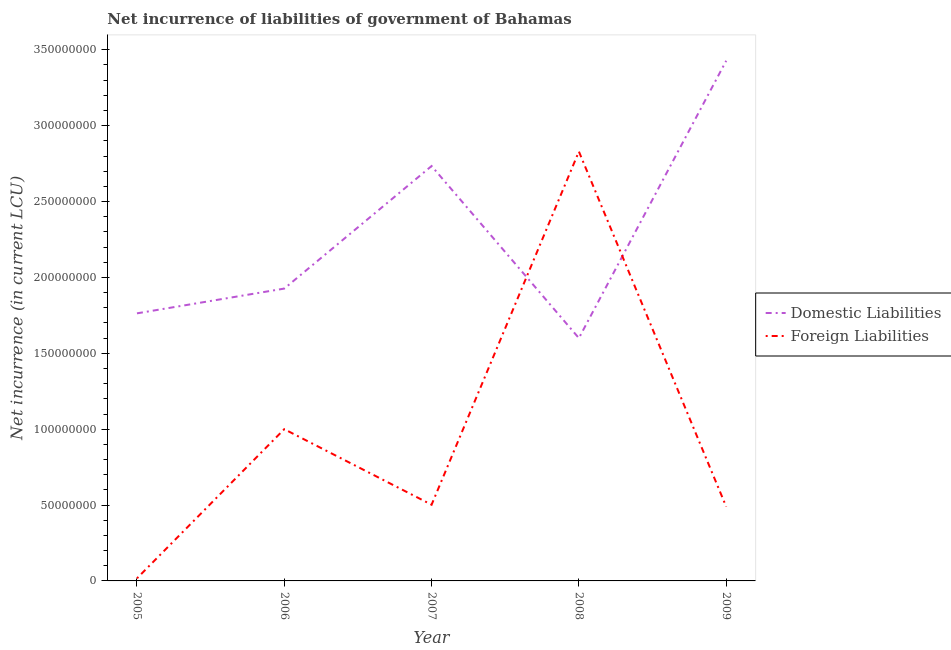How many different coloured lines are there?
Provide a short and direct response. 2. What is the net incurrence of domestic liabilities in 2007?
Offer a terse response. 2.73e+08. Across all years, what is the maximum net incurrence of domestic liabilities?
Make the answer very short. 3.43e+08. Across all years, what is the minimum net incurrence of foreign liabilities?
Offer a terse response. 1.70e+06. In which year was the net incurrence of foreign liabilities maximum?
Ensure brevity in your answer.  2008. What is the total net incurrence of foreign liabilities in the graph?
Provide a succinct answer. 4.84e+08. What is the difference between the net incurrence of domestic liabilities in 2006 and that in 2007?
Ensure brevity in your answer.  -8.08e+07. What is the difference between the net incurrence of foreign liabilities in 2009 and the net incurrence of domestic liabilities in 2005?
Provide a short and direct response. -1.27e+08. What is the average net incurrence of domestic liabilities per year?
Your answer should be very brief. 2.29e+08. In the year 2008, what is the difference between the net incurrence of domestic liabilities and net incurrence of foreign liabilities?
Offer a very short reply. -1.23e+08. In how many years, is the net incurrence of domestic liabilities greater than 220000000 LCU?
Provide a short and direct response. 2. What is the ratio of the net incurrence of domestic liabilities in 2006 to that in 2007?
Ensure brevity in your answer.  0.7. What is the difference between the highest and the second highest net incurrence of domestic liabilities?
Ensure brevity in your answer.  6.94e+07. What is the difference between the highest and the lowest net incurrence of foreign liabilities?
Make the answer very short. 2.81e+08. Is the net incurrence of domestic liabilities strictly less than the net incurrence of foreign liabilities over the years?
Your answer should be compact. No. How many lines are there?
Offer a terse response. 2. Does the graph contain any zero values?
Make the answer very short. No. Does the graph contain grids?
Your answer should be very brief. No. What is the title of the graph?
Offer a terse response. Net incurrence of liabilities of government of Bahamas. Does "Central government" appear as one of the legend labels in the graph?
Offer a very short reply. No. What is the label or title of the Y-axis?
Your answer should be compact. Net incurrence (in current LCU). What is the Net incurrence (in current LCU) in Domestic Liabilities in 2005?
Offer a very short reply. 1.76e+08. What is the Net incurrence (in current LCU) in Foreign Liabilities in 2005?
Ensure brevity in your answer.  1.70e+06. What is the Net incurrence (in current LCU) in Domestic Liabilities in 2006?
Offer a terse response. 1.93e+08. What is the Net incurrence (in current LCU) in Domestic Liabilities in 2007?
Your answer should be very brief. 2.73e+08. What is the Net incurrence (in current LCU) of Foreign Liabilities in 2007?
Keep it short and to the point. 5.02e+07. What is the Net incurrence (in current LCU) of Domestic Liabilities in 2008?
Provide a short and direct response. 1.60e+08. What is the Net incurrence (in current LCU) of Foreign Liabilities in 2008?
Give a very brief answer. 2.83e+08. What is the Net incurrence (in current LCU) in Domestic Liabilities in 2009?
Keep it short and to the point. 3.43e+08. What is the Net incurrence (in current LCU) in Foreign Liabilities in 2009?
Provide a short and direct response. 4.89e+07. Across all years, what is the maximum Net incurrence (in current LCU) in Domestic Liabilities?
Offer a terse response. 3.43e+08. Across all years, what is the maximum Net incurrence (in current LCU) of Foreign Liabilities?
Keep it short and to the point. 2.83e+08. Across all years, what is the minimum Net incurrence (in current LCU) of Domestic Liabilities?
Ensure brevity in your answer.  1.60e+08. Across all years, what is the minimum Net incurrence (in current LCU) in Foreign Liabilities?
Provide a succinct answer. 1.70e+06. What is the total Net incurrence (in current LCU) in Domestic Liabilities in the graph?
Offer a very short reply. 1.15e+09. What is the total Net incurrence (in current LCU) of Foreign Liabilities in the graph?
Ensure brevity in your answer.  4.84e+08. What is the difference between the Net incurrence (in current LCU) in Domestic Liabilities in 2005 and that in 2006?
Give a very brief answer. -1.63e+07. What is the difference between the Net incurrence (in current LCU) in Foreign Liabilities in 2005 and that in 2006?
Offer a very short reply. -9.83e+07. What is the difference between the Net incurrence (in current LCU) of Domestic Liabilities in 2005 and that in 2007?
Offer a terse response. -9.71e+07. What is the difference between the Net incurrence (in current LCU) of Foreign Liabilities in 2005 and that in 2007?
Give a very brief answer. -4.85e+07. What is the difference between the Net incurrence (in current LCU) of Domestic Liabilities in 2005 and that in 2008?
Your response must be concise. 1.63e+07. What is the difference between the Net incurrence (in current LCU) of Foreign Liabilities in 2005 and that in 2008?
Provide a succinct answer. -2.81e+08. What is the difference between the Net incurrence (in current LCU) in Domestic Liabilities in 2005 and that in 2009?
Give a very brief answer. -1.66e+08. What is the difference between the Net incurrence (in current LCU) in Foreign Liabilities in 2005 and that in 2009?
Keep it short and to the point. -4.72e+07. What is the difference between the Net incurrence (in current LCU) in Domestic Liabilities in 2006 and that in 2007?
Ensure brevity in your answer.  -8.08e+07. What is the difference between the Net incurrence (in current LCU) of Foreign Liabilities in 2006 and that in 2007?
Your answer should be compact. 4.98e+07. What is the difference between the Net incurrence (in current LCU) in Domestic Liabilities in 2006 and that in 2008?
Give a very brief answer. 3.26e+07. What is the difference between the Net incurrence (in current LCU) of Foreign Liabilities in 2006 and that in 2008?
Make the answer very short. -1.83e+08. What is the difference between the Net incurrence (in current LCU) of Domestic Liabilities in 2006 and that in 2009?
Make the answer very short. -1.50e+08. What is the difference between the Net incurrence (in current LCU) of Foreign Liabilities in 2006 and that in 2009?
Provide a short and direct response. 5.11e+07. What is the difference between the Net incurrence (in current LCU) in Domestic Liabilities in 2007 and that in 2008?
Your response must be concise. 1.13e+08. What is the difference between the Net incurrence (in current LCU) in Foreign Liabilities in 2007 and that in 2008?
Ensure brevity in your answer.  -2.33e+08. What is the difference between the Net incurrence (in current LCU) of Domestic Liabilities in 2007 and that in 2009?
Offer a terse response. -6.94e+07. What is the difference between the Net incurrence (in current LCU) of Foreign Liabilities in 2007 and that in 2009?
Keep it short and to the point. 1.27e+06. What is the difference between the Net incurrence (in current LCU) in Domestic Liabilities in 2008 and that in 2009?
Ensure brevity in your answer.  -1.83e+08. What is the difference between the Net incurrence (in current LCU) in Foreign Liabilities in 2008 and that in 2009?
Ensure brevity in your answer.  2.34e+08. What is the difference between the Net incurrence (in current LCU) in Domestic Liabilities in 2005 and the Net incurrence (in current LCU) in Foreign Liabilities in 2006?
Your answer should be compact. 7.63e+07. What is the difference between the Net incurrence (in current LCU) of Domestic Liabilities in 2005 and the Net incurrence (in current LCU) of Foreign Liabilities in 2007?
Your response must be concise. 1.26e+08. What is the difference between the Net incurrence (in current LCU) in Domestic Liabilities in 2005 and the Net incurrence (in current LCU) in Foreign Liabilities in 2008?
Keep it short and to the point. -1.07e+08. What is the difference between the Net incurrence (in current LCU) in Domestic Liabilities in 2005 and the Net incurrence (in current LCU) in Foreign Liabilities in 2009?
Provide a short and direct response. 1.27e+08. What is the difference between the Net incurrence (in current LCU) of Domestic Liabilities in 2006 and the Net incurrence (in current LCU) of Foreign Liabilities in 2007?
Ensure brevity in your answer.  1.42e+08. What is the difference between the Net incurrence (in current LCU) of Domestic Liabilities in 2006 and the Net incurrence (in current LCU) of Foreign Liabilities in 2008?
Give a very brief answer. -9.03e+07. What is the difference between the Net incurrence (in current LCU) of Domestic Liabilities in 2006 and the Net incurrence (in current LCU) of Foreign Liabilities in 2009?
Your response must be concise. 1.44e+08. What is the difference between the Net incurrence (in current LCU) in Domestic Liabilities in 2007 and the Net incurrence (in current LCU) in Foreign Liabilities in 2008?
Offer a very short reply. -9.55e+06. What is the difference between the Net incurrence (in current LCU) of Domestic Liabilities in 2007 and the Net incurrence (in current LCU) of Foreign Liabilities in 2009?
Ensure brevity in your answer.  2.24e+08. What is the difference between the Net incurrence (in current LCU) in Domestic Liabilities in 2008 and the Net incurrence (in current LCU) in Foreign Liabilities in 2009?
Give a very brief answer. 1.11e+08. What is the average Net incurrence (in current LCU) of Domestic Liabilities per year?
Your response must be concise. 2.29e+08. What is the average Net incurrence (in current LCU) of Foreign Liabilities per year?
Provide a short and direct response. 9.68e+07. In the year 2005, what is the difference between the Net incurrence (in current LCU) in Domestic Liabilities and Net incurrence (in current LCU) in Foreign Liabilities?
Give a very brief answer. 1.75e+08. In the year 2006, what is the difference between the Net incurrence (in current LCU) in Domestic Liabilities and Net incurrence (in current LCU) in Foreign Liabilities?
Your answer should be very brief. 9.26e+07. In the year 2007, what is the difference between the Net incurrence (in current LCU) of Domestic Liabilities and Net incurrence (in current LCU) of Foreign Liabilities?
Your answer should be compact. 2.23e+08. In the year 2008, what is the difference between the Net incurrence (in current LCU) in Domestic Liabilities and Net incurrence (in current LCU) in Foreign Liabilities?
Your answer should be very brief. -1.23e+08. In the year 2009, what is the difference between the Net incurrence (in current LCU) in Domestic Liabilities and Net incurrence (in current LCU) in Foreign Liabilities?
Ensure brevity in your answer.  2.94e+08. What is the ratio of the Net incurrence (in current LCU) of Domestic Liabilities in 2005 to that in 2006?
Keep it short and to the point. 0.92. What is the ratio of the Net incurrence (in current LCU) in Foreign Liabilities in 2005 to that in 2006?
Make the answer very short. 0.02. What is the ratio of the Net incurrence (in current LCU) in Domestic Liabilities in 2005 to that in 2007?
Provide a short and direct response. 0.64. What is the ratio of the Net incurrence (in current LCU) in Foreign Liabilities in 2005 to that in 2007?
Keep it short and to the point. 0.03. What is the ratio of the Net incurrence (in current LCU) of Domestic Liabilities in 2005 to that in 2008?
Provide a succinct answer. 1.1. What is the ratio of the Net incurrence (in current LCU) of Foreign Liabilities in 2005 to that in 2008?
Your answer should be very brief. 0.01. What is the ratio of the Net incurrence (in current LCU) in Domestic Liabilities in 2005 to that in 2009?
Ensure brevity in your answer.  0.51. What is the ratio of the Net incurrence (in current LCU) of Foreign Liabilities in 2005 to that in 2009?
Provide a succinct answer. 0.03. What is the ratio of the Net incurrence (in current LCU) of Domestic Liabilities in 2006 to that in 2007?
Keep it short and to the point. 0.7. What is the ratio of the Net incurrence (in current LCU) in Foreign Liabilities in 2006 to that in 2007?
Provide a succinct answer. 1.99. What is the ratio of the Net incurrence (in current LCU) in Domestic Liabilities in 2006 to that in 2008?
Provide a succinct answer. 1.2. What is the ratio of the Net incurrence (in current LCU) of Foreign Liabilities in 2006 to that in 2008?
Your response must be concise. 0.35. What is the ratio of the Net incurrence (in current LCU) of Domestic Liabilities in 2006 to that in 2009?
Your answer should be compact. 0.56. What is the ratio of the Net incurrence (in current LCU) in Foreign Liabilities in 2006 to that in 2009?
Ensure brevity in your answer.  2.04. What is the ratio of the Net incurrence (in current LCU) in Domestic Liabilities in 2007 to that in 2008?
Provide a short and direct response. 1.71. What is the ratio of the Net incurrence (in current LCU) in Foreign Liabilities in 2007 to that in 2008?
Offer a terse response. 0.18. What is the ratio of the Net incurrence (in current LCU) in Domestic Liabilities in 2007 to that in 2009?
Your answer should be compact. 0.8. What is the ratio of the Net incurrence (in current LCU) of Foreign Liabilities in 2007 to that in 2009?
Your answer should be compact. 1.03. What is the ratio of the Net incurrence (in current LCU) in Domestic Liabilities in 2008 to that in 2009?
Ensure brevity in your answer.  0.47. What is the ratio of the Net incurrence (in current LCU) in Foreign Liabilities in 2008 to that in 2009?
Your answer should be compact. 5.78. What is the difference between the highest and the second highest Net incurrence (in current LCU) in Domestic Liabilities?
Your answer should be compact. 6.94e+07. What is the difference between the highest and the second highest Net incurrence (in current LCU) in Foreign Liabilities?
Provide a succinct answer. 1.83e+08. What is the difference between the highest and the lowest Net incurrence (in current LCU) of Domestic Liabilities?
Offer a very short reply. 1.83e+08. What is the difference between the highest and the lowest Net incurrence (in current LCU) in Foreign Liabilities?
Your answer should be very brief. 2.81e+08. 